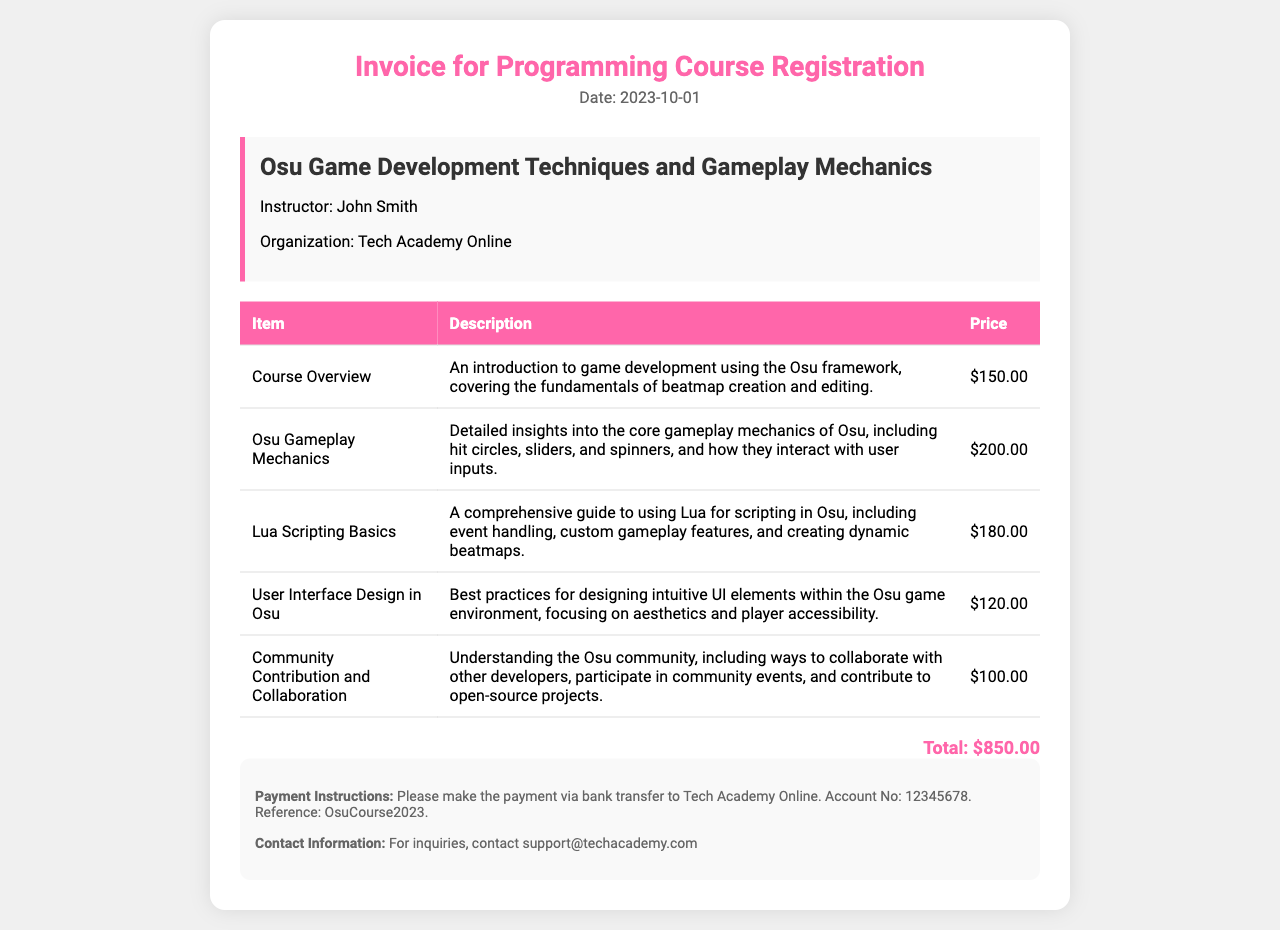What is the date of the invoice? The date is mentioned at the top of the invoice.
Answer: 2023-10-01 Who is the instructor for the course? The instructor's name is listed in the course information section.
Answer: John Smith What is the price of the course overview? The price is indicated under the "Price" column for the course overview item.
Answer: $150.00 How much does the "User Interface Design in Osu" section cost? This information can be found in the table under the corresponding item.
Answer: $120.00 What is the total amount due for the course? The total is presented at the bottom of the invoice.
Answer: $850.00 What is included in the "Osu Gameplay Mechanics" description? The description for this item provides insights into gameplay mechanics, which is a core focus of the course.
Answer: Core gameplay mechanics of Osu What is the payment method mentioned in the invoice? The payment instructions detail how to make the payment.
Answer: Bank transfer What is the major focus of the course? The main topic of the course is specified in the header of the course information section.
Answer: Osu Game Development Techniques and Gameplay Mechanics What is the organization providing the course? The organization is stated in the course information section of the invoice.
Answer: Tech Academy Online 